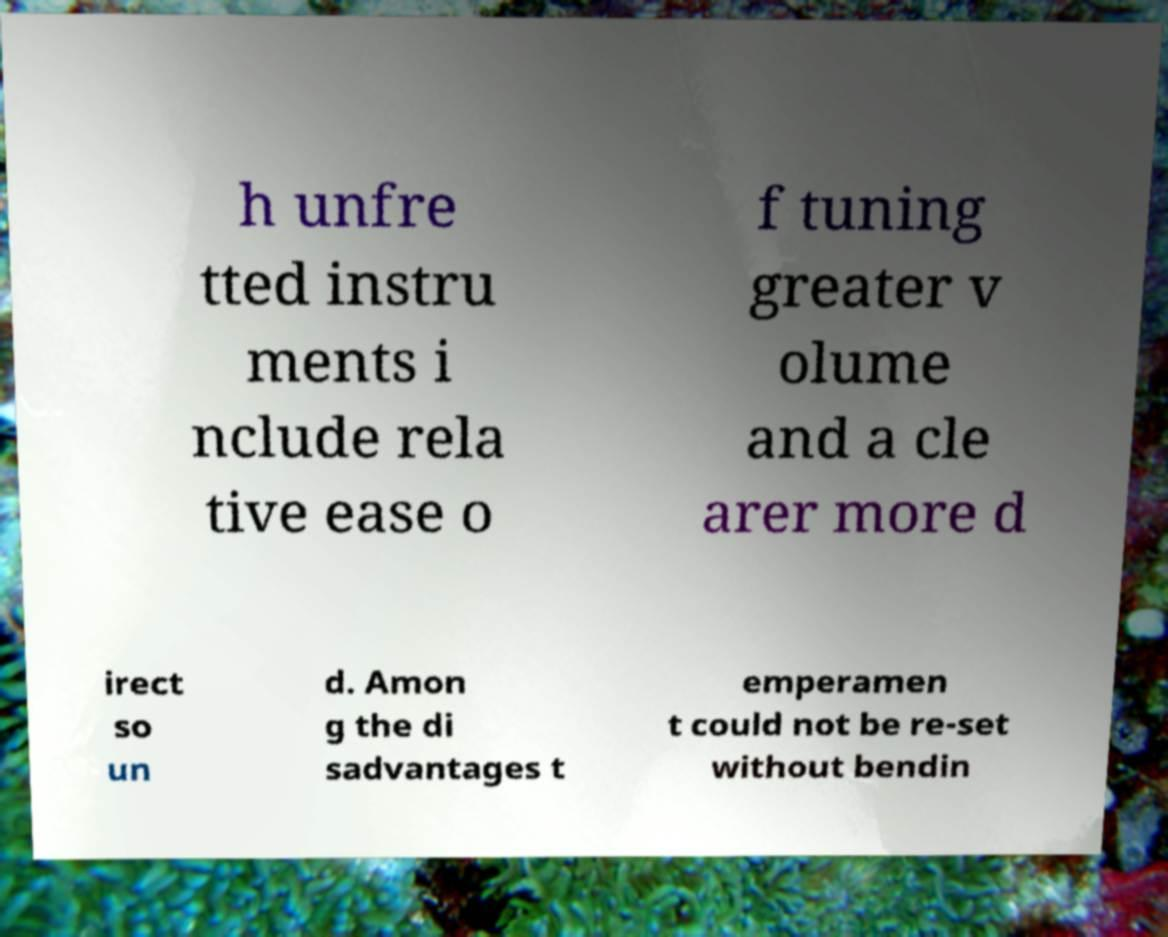Could you extract and type out the text from this image? h unfre tted instru ments i nclude rela tive ease o f tuning greater v olume and a cle arer more d irect so un d. Amon g the di sadvantages t emperamen t could not be re-set without bendin 